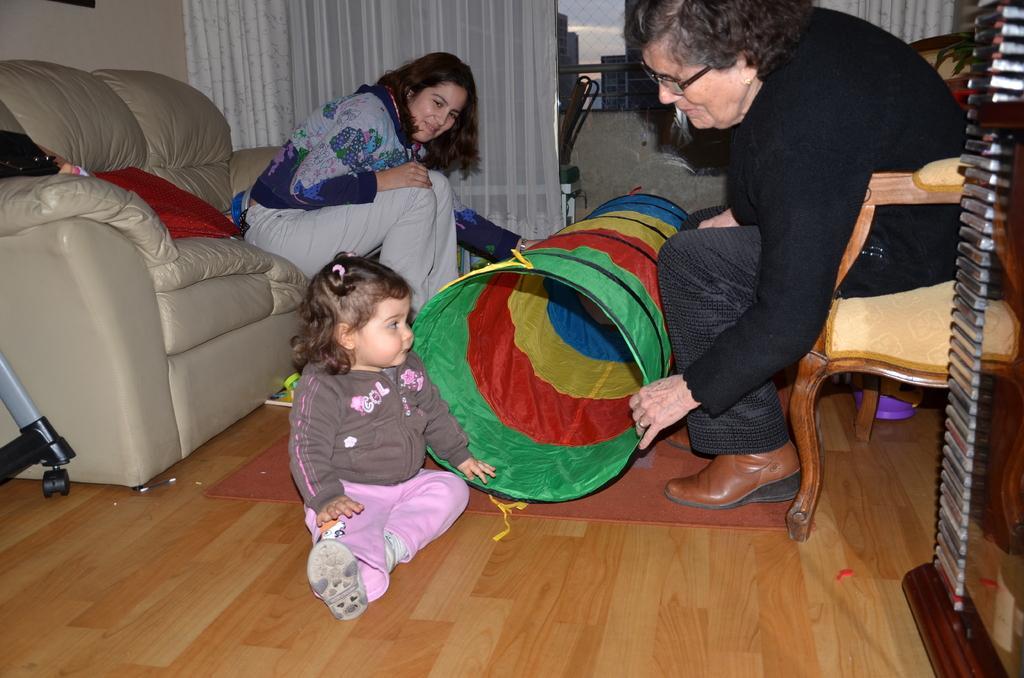Please provide a concise description of this image. In this picture I can see a couple of women sitting and I can see a sofa and looks like a chair on the right side and I can see a girl sitting on the floor and I can see cloth basket and curtains and I can see buildings from the glass window and I can see sky 